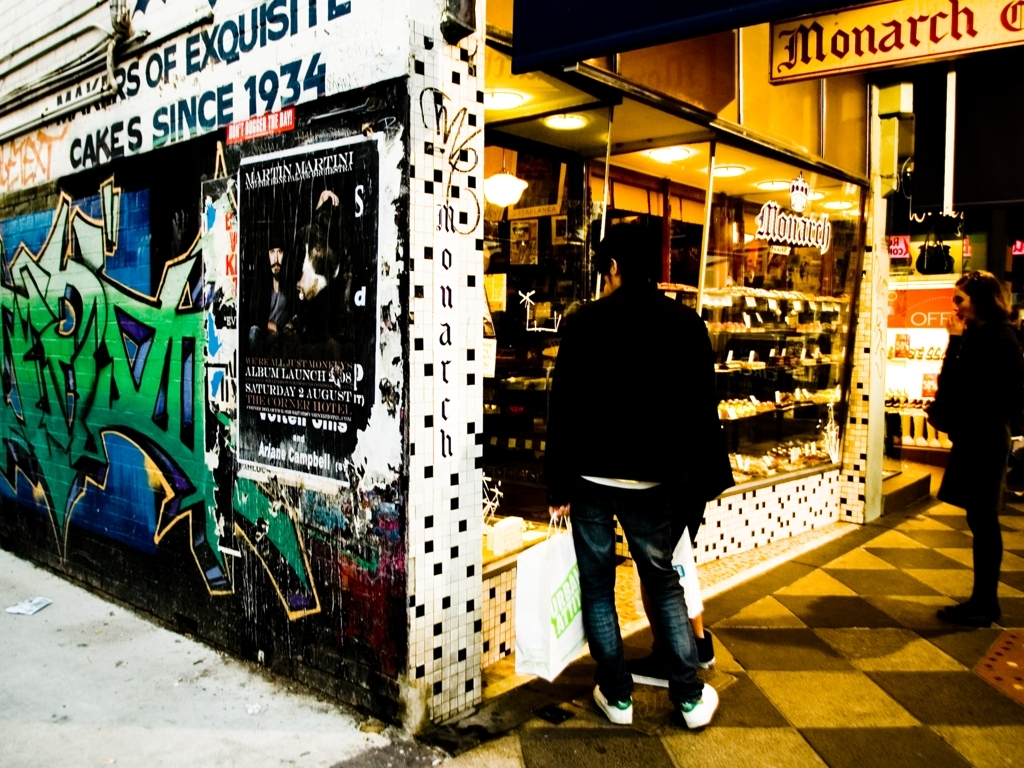Has the background lost a significant amount of texture detail?
A. Yes
B. No
Answer with the option's letter from the given choices directly. A. The background does exhibit a notable loss of texture detail, particularly evident in the graffiti and posters, where the finer details are not clearly visible. Various factors, such as image compression and lighting conditions, can contribute to this effect. 